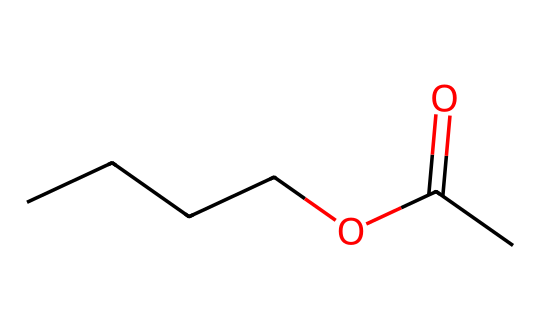What is the molecular formula of butyl acetate? The SMILES representation indicates that butyl acetate consists of four carbon atoms in the butyl group (CCCC), one carbonyl group (C=O), and another carbon in the acetate part (C). Combining these gives a total of six carbons, twelve hydrogens, and two oxygens, resulting in the molecular formula C6H12O2.
Answer: C6H12O2 How many carbon atoms are present in butyl acetate? From the SMILES representation, there are four carbon atoms in the butyl chain (CCCC) plus one carbon in the carbonyl and another in the acetate, totaling six carbon atoms.
Answer: 6 What type of chemical is butyl acetate? Given that butyl acetate has both an ester functional group (the -COO- part) and comes from a carboxylic acid and alcohol, it categorizes as an ester.
Answer: ester What type of bond connects the carbonyl carbon to the oxygen in butyl acetate? The carbonyl group in esters features a double bond between the carbon atom and the oxygen atom, which is characteristic of carbonyl groups.
Answer: double bond Why does butyl acetate have a fruity aroma used in flavorings? The specific arrangement of atoms, including the ester functional group and the long butyl chain, allows butyl acetate to exhibit a volatile nature that contributes to fruity aromas, common in esters.
Answer: fruity aroma How many oxygen atoms are found in the structure of butyl acetate? Analyzing the SMILES representation reveals two oxygen atoms: one in the carbonyl group (C=O) and one in the ester bond (O).
Answer: 2 Which part of the butyl acetate molecule is responsible for its solubility in organic solvents? The long hydrophobic butyl chain provides non-polar characteristics, while the polar ester group (C=O and O) allows solubility in polar organic solvents, making it a good candidate for various flavorings.
Answer: ester group 